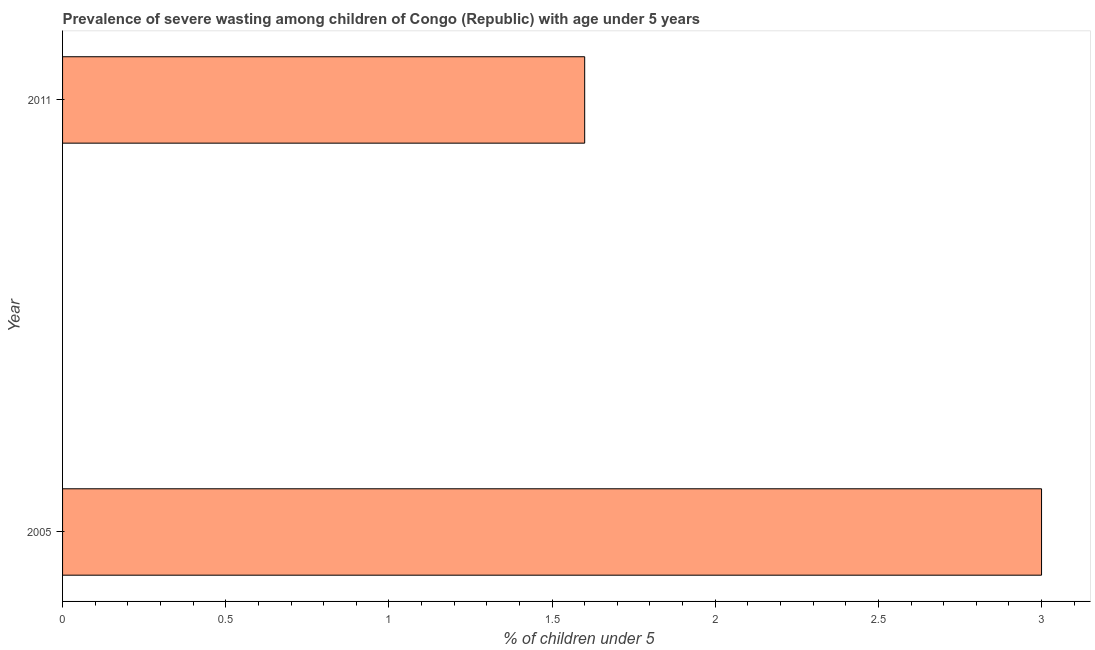Does the graph contain any zero values?
Your response must be concise. No. What is the title of the graph?
Give a very brief answer. Prevalence of severe wasting among children of Congo (Republic) with age under 5 years. What is the label or title of the X-axis?
Keep it short and to the point.  % of children under 5. What is the label or title of the Y-axis?
Ensure brevity in your answer.  Year. What is the prevalence of severe wasting in 2005?
Provide a short and direct response. 3. Across all years, what is the minimum prevalence of severe wasting?
Your response must be concise. 1.6. In which year was the prevalence of severe wasting maximum?
Give a very brief answer. 2005. In which year was the prevalence of severe wasting minimum?
Your answer should be very brief. 2011. What is the sum of the prevalence of severe wasting?
Your answer should be compact. 4.6. What is the difference between the prevalence of severe wasting in 2005 and 2011?
Provide a short and direct response. 1.4. What is the average prevalence of severe wasting per year?
Keep it short and to the point. 2.3. What is the median prevalence of severe wasting?
Offer a terse response. 2.3. In how many years, is the prevalence of severe wasting greater than 2.3 %?
Your answer should be very brief. 1. What is the ratio of the prevalence of severe wasting in 2005 to that in 2011?
Your answer should be very brief. 1.88. Is the prevalence of severe wasting in 2005 less than that in 2011?
Offer a terse response. No. Are all the bars in the graph horizontal?
Ensure brevity in your answer.  Yes. How many years are there in the graph?
Give a very brief answer. 2. What is the difference between two consecutive major ticks on the X-axis?
Provide a succinct answer. 0.5. What is the  % of children under 5 in 2005?
Provide a succinct answer. 3. What is the  % of children under 5 in 2011?
Keep it short and to the point. 1.6. What is the difference between the  % of children under 5 in 2005 and 2011?
Your answer should be compact. 1.4. What is the ratio of the  % of children under 5 in 2005 to that in 2011?
Ensure brevity in your answer.  1.88. 